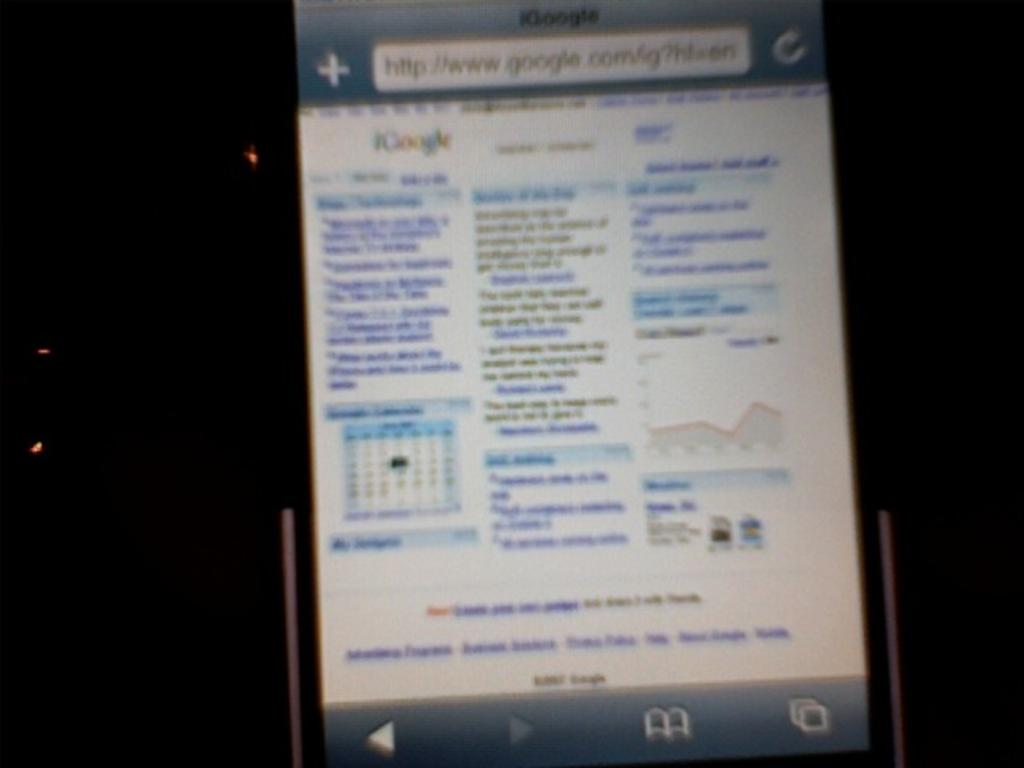<image>
Provide a brief description of the given image. A blurry shot of the screen of a phone on google.com. 